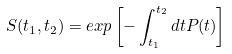Convert formula to latex. <formula><loc_0><loc_0><loc_500><loc_500>S ( t _ { 1 } , t _ { 2 } ) = e x p \left [ - \int _ { t _ { 1 } } ^ { t _ { 2 } } d t P ( t ) \right ]</formula> 